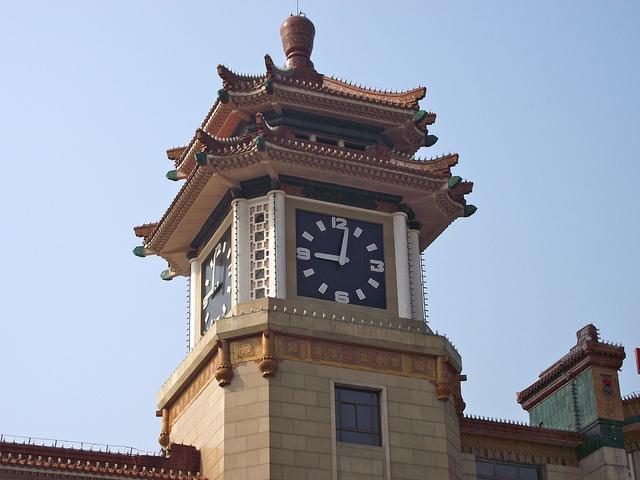How many numbers are on the clock?
Give a very brief answer. 4. How many clock are shown?
Give a very brief answer. 2. How many clocks are in the picture?
Give a very brief answer. 2. 